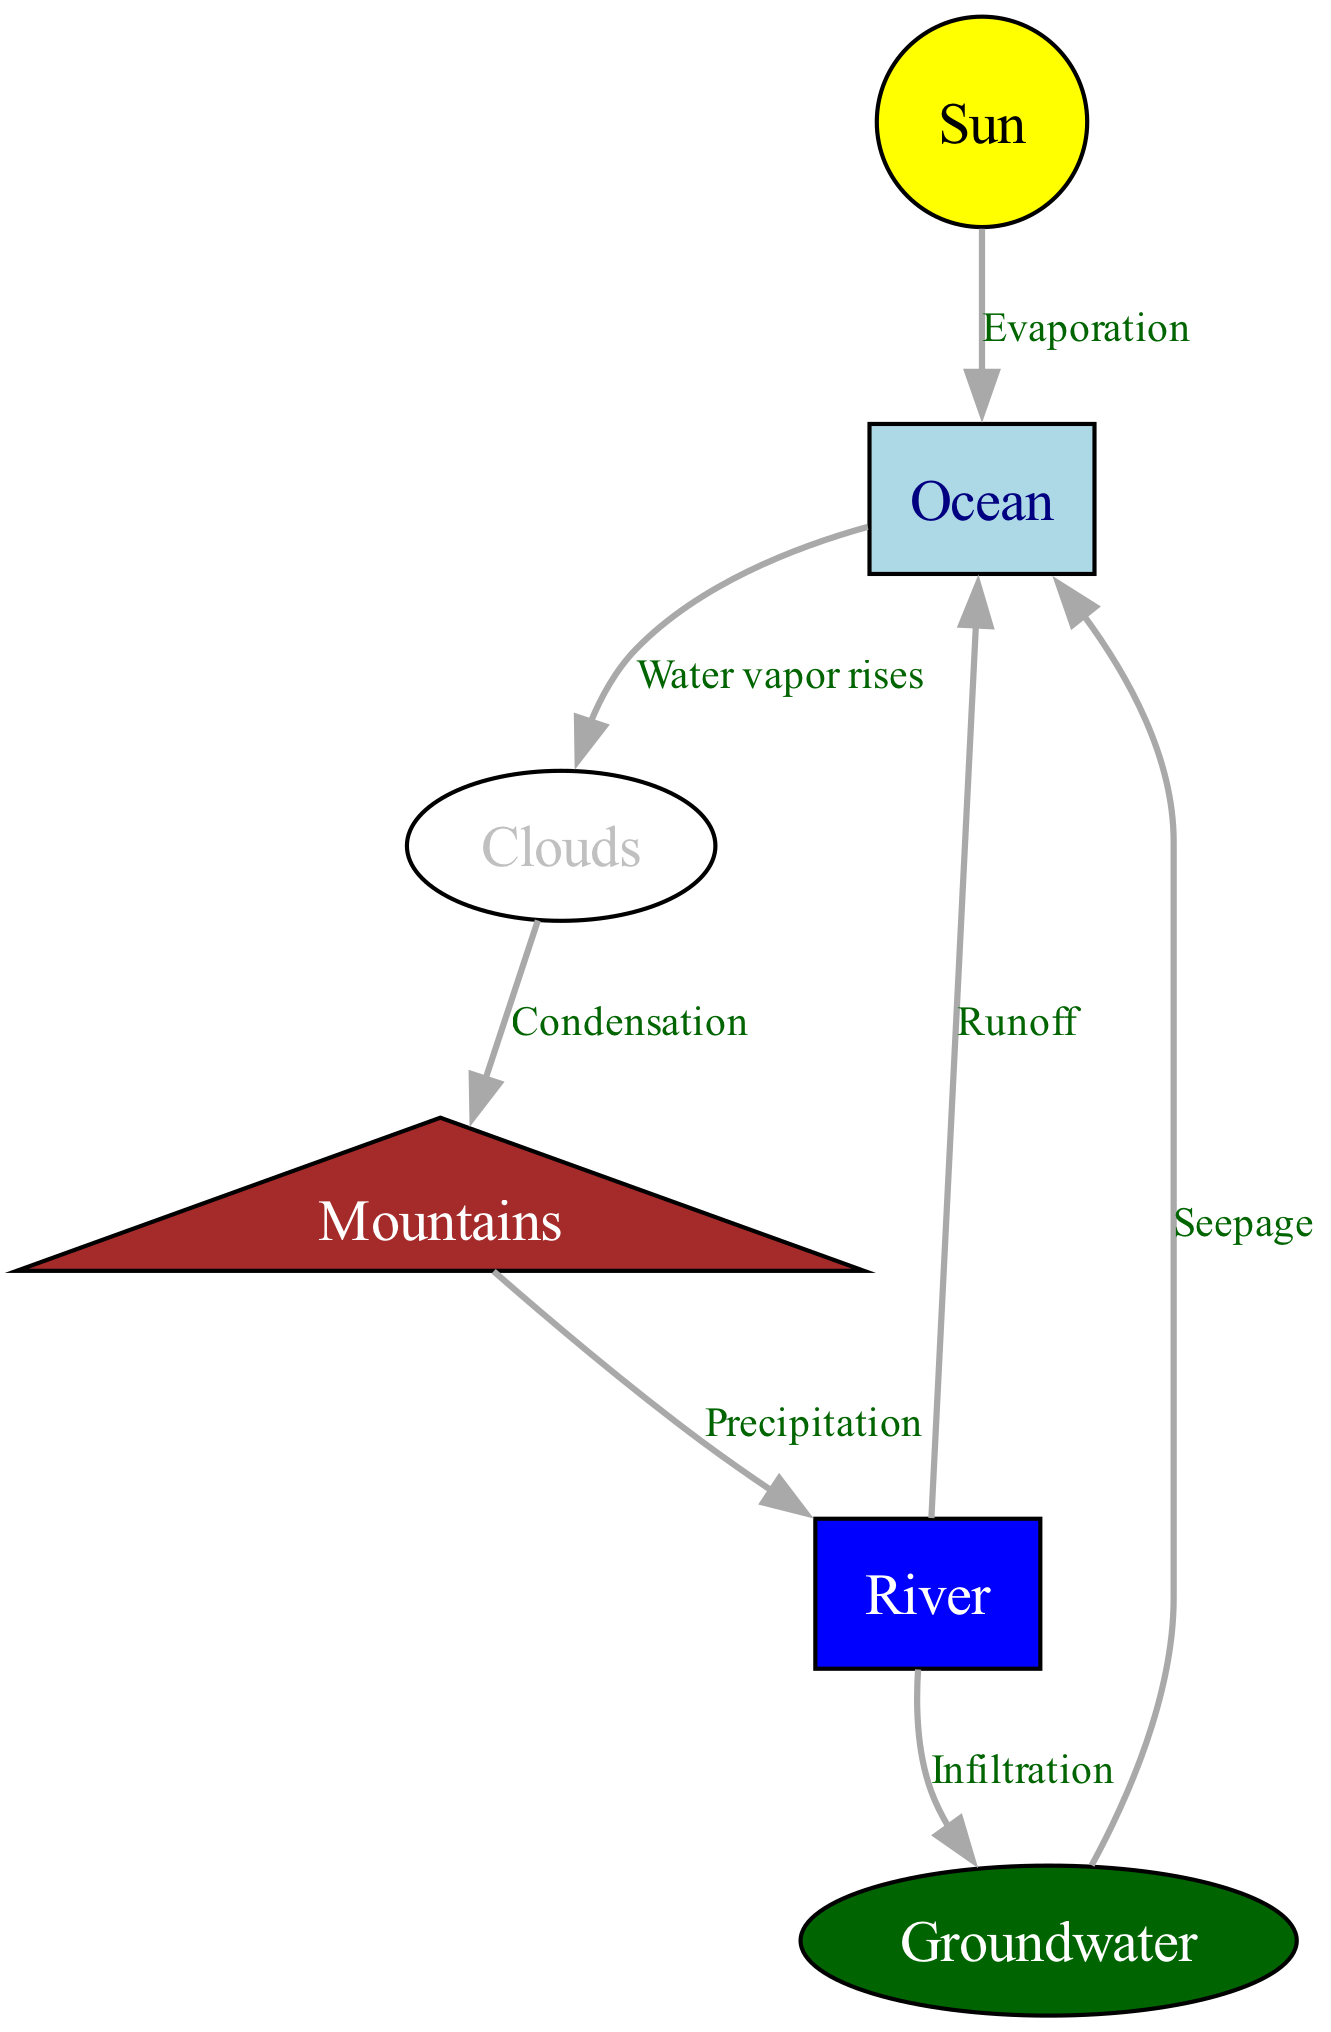What process does the sun initiate in the water cycle? The diagram shows that the sun is connected to the ocean through the edge labeled "Evaporation," indicating that the sun initiates the evaporation process by heating the ocean.
Answer: Evaporation How many main elements are involved in the water cycle? The diagram lists six nodes: sun, ocean, clouds, mountains, river, and groundwater. Counting these gives a total of six elements involved.
Answer: Six What occurs between clouds and mountains? The edge connecting clouds to mountains is labeled "Condensation," indicating that the process occurring here is condensation, where water vapor turns into liquid water.
Answer: Condensation Where does runoff from the river lead to? The diagram depicts an edge labeled "Runoff" connecting the river to the ocean, indicating that runoff from the river flows back into the ocean.
Answer: Ocean Which process occurs when water moves from the river to the groundwater? The edge on the diagram labeled "Infiltration" indicates that this process occurs as water from the river seeps into the groundwater.
Answer: Infiltration What is the sequence of processes starting from the ocean to precipitation? The sequence begins with water vapor rising from the ocean (evaporation), moving to clouds (water vapor rises), then condensing in clouds to form precipitation that falls onto mountains (precipitation).
Answer: Evaporation, water vapor rises, condensation, precipitation Which element in the diagram represents groundwater? The node labeled "Groundwater" specifically identifies this element in the diagram, and it typically represents the water stored underground.
Answer: Groundwater What is the last process described in the water cycle? The last process illustrated in the diagram shows groundwater seeping back into the ocean, labeled as "Seepage." This demonstrates the return of water to the ocean from groundwater.
Answer: Seepage 